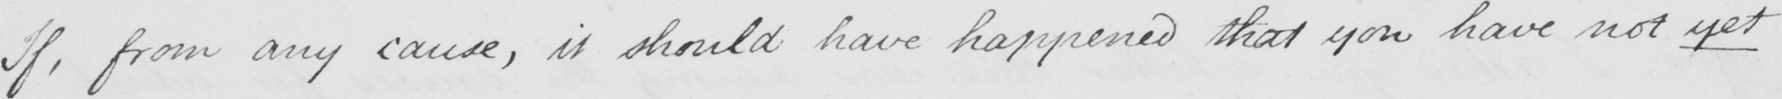Transcribe the text shown in this historical manuscript line. If , from any cause , it should have happened that you have not yet 